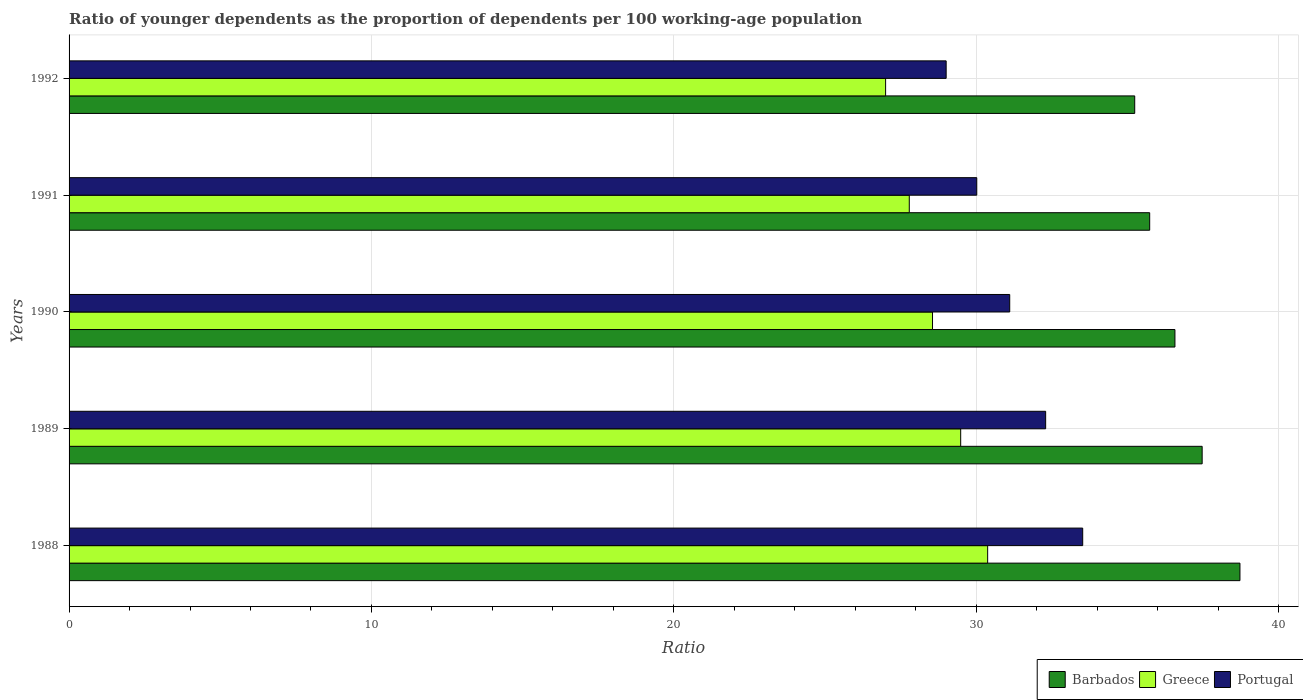How many different coloured bars are there?
Your answer should be very brief. 3. How many groups of bars are there?
Offer a very short reply. 5. Are the number of bars on each tick of the Y-axis equal?
Provide a succinct answer. Yes. How many bars are there on the 2nd tick from the bottom?
Your response must be concise. 3. In how many cases, is the number of bars for a given year not equal to the number of legend labels?
Give a very brief answer. 0. What is the age dependency ratio(young) in Barbados in 1990?
Your answer should be compact. 36.57. Across all years, what is the maximum age dependency ratio(young) in Barbados?
Ensure brevity in your answer.  38.72. Across all years, what is the minimum age dependency ratio(young) in Portugal?
Your answer should be compact. 29. In which year was the age dependency ratio(young) in Greece maximum?
Offer a terse response. 1988. What is the total age dependency ratio(young) in Portugal in the graph?
Your answer should be compact. 155.94. What is the difference between the age dependency ratio(young) in Portugal in 1989 and that in 1992?
Provide a short and direct response. 3.29. What is the difference between the age dependency ratio(young) in Greece in 1990 and the age dependency ratio(young) in Barbados in 1989?
Offer a very short reply. -8.92. What is the average age dependency ratio(young) in Greece per year?
Provide a short and direct response. 28.64. In the year 1992, what is the difference between the age dependency ratio(young) in Barbados and age dependency ratio(young) in Greece?
Make the answer very short. 8.24. What is the ratio of the age dependency ratio(young) in Barbados in 1989 to that in 1992?
Offer a very short reply. 1.06. Is the difference between the age dependency ratio(young) in Barbados in 1988 and 1991 greater than the difference between the age dependency ratio(young) in Greece in 1988 and 1991?
Provide a short and direct response. Yes. What is the difference between the highest and the second highest age dependency ratio(young) in Barbados?
Your answer should be very brief. 1.25. What is the difference between the highest and the lowest age dependency ratio(young) in Greece?
Offer a very short reply. 3.37. In how many years, is the age dependency ratio(young) in Portugal greater than the average age dependency ratio(young) in Portugal taken over all years?
Make the answer very short. 2. Is the sum of the age dependency ratio(young) in Greece in 1988 and 1990 greater than the maximum age dependency ratio(young) in Barbados across all years?
Your response must be concise. Yes. What does the 1st bar from the bottom in 1988 represents?
Make the answer very short. Barbados. Are the values on the major ticks of X-axis written in scientific E-notation?
Offer a terse response. No. Where does the legend appear in the graph?
Offer a terse response. Bottom right. What is the title of the graph?
Provide a succinct answer. Ratio of younger dependents as the proportion of dependents per 100 working-age population. Does "Central Europe" appear as one of the legend labels in the graph?
Give a very brief answer. No. What is the label or title of the X-axis?
Keep it short and to the point. Ratio. What is the label or title of the Y-axis?
Make the answer very short. Years. What is the Ratio of Barbados in 1988?
Keep it short and to the point. 38.72. What is the Ratio in Greece in 1988?
Make the answer very short. 30.38. What is the Ratio in Portugal in 1988?
Give a very brief answer. 33.52. What is the Ratio of Barbados in 1989?
Keep it short and to the point. 37.47. What is the Ratio in Greece in 1989?
Provide a succinct answer. 29.49. What is the Ratio in Portugal in 1989?
Your response must be concise. 32.3. What is the Ratio in Barbados in 1990?
Your answer should be very brief. 36.57. What is the Ratio of Greece in 1990?
Offer a terse response. 28.55. What is the Ratio in Portugal in 1990?
Keep it short and to the point. 31.11. What is the Ratio of Barbados in 1991?
Give a very brief answer. 35.74. What is the Ratio of Greece in 1991?
Provide a succinct answer. 27.79. What is the Ratio in Portugal in 1991?
Offer a very short reply. 30.02. What is the Ratio in Barbados in 1992?
Give a very brief answer. 35.24. What is the Ratio of Greece in 1992?
Your response must be concise. 27. What is the Ratio of Portugal in 1992?
Ensure brevity in your answer.  29. Across all years, what is the maximum Ratio of Barbados?
Your response must be concise. 38.72. Across all years, what is the maximum Ratio of Greece?
Keep it short and to the point. 30.38. Across all years, what is the maximum Ratio of Portugal?
Offer a very short reply. 33.52. Across all years, what is the minimum Ratio in Barbados?
Make the answer very short. 35.24. Across all years, what is the minimum Ratio in Greece?
Provide a succinct answer. 27. Across all years, what is the minimum Ratio in Portugal?
Your answer should be very brief. 29. What is the total Ratio in Barbados in the graph?
Provide a succinct answer. 183.74. What is the total Ratio of Greece in the graph?
Keep it short and to the point. 143.2. What is the total Ratio of Portugal in the graph?
Your answer should be compact. 155.94. What is the difference between the Ratio in Barbados in 1988 and that in 1989?
Provide a succinct answer. 1.25. What is the difference between the Ratio of Greece in 1988 and that in 1989?
Give a very brief answer. 0.89. What is the difference between the Ratio in Portugal in 1988 and that in 1989?
Your answer should be compact. 1.23. What is the difference between the Ratio in Barbados in 1988 and that in 1990?
Give a very brief answer. 2.15. What is the difference between the Ratio in Greece in 1988 and that in 1990?
Offer a terse response. 1.82. What is the difference between the Ratio of Portugal in 1988 and that in 1990?
Provide a succinct answer. 2.41. What is the difference between the Ratio in Barbados in 1988 and that in 1991?
Provide a short and direct response. 2.98. What is the difference between the Ratio of Greece in 1988 and that in 1991?
Give a very brief answer. 2.59. What is the difference between the Ratio of Portugal in 1988 and that in 1991?
Your answer should be very brief. 3.5. What is the difference between the Ratio in Barbados in 1988 and that in 1992?
Offer a terse response. 3.48. What is the difference between the Ratio of Greece in 1988 and that in 1992?
Offer a very short reply. 3.37. What is the difference between the Ratio in Portugal in 1988 and that in 1992?
Offer a very short reply. 4.52. What is the difference between the Ratio in Barbados in 1989 and that in 1990?
Keep it short and to the point. 0.9. What is the difference between the Ratio in Greece in 1989 and that in 1990?
Ensure brevity in your answer.  0.93. What is the difference between the Ratio in Portugal in 1989 and that in 1990?
Keep it short and to the point. 1.19. What is the difference between the Ratio of Barbados in 1989 and that in 1991?
Provide a short and direct response. 1.74. What is the difference between the Ratio in Greece in 1989 and that in 1991?
Provide a succinct answer. 1.7. What is the difference between the Ratio of Portugal in 1989 and that in 1991?
Your answer should be very brief. 2.28. What is the difference between the Ratio of Barbados in 1989 and that in 1992?
Provide a succinct answer. 2.23. What is the difference between the Ratio in Greece in 1989 and that in 1992?
Provide a succinct answer. 2.48. What is the difference between the Ratio in Portugal in 1989 and that in 1992?
Provide a short and direct response. 3.29. What is the difference between the Ratio in Barbados in 1990 and that in 1991?
Offer a terse response. 0.83. What is the difference between the Ratio in Greece in 1990 and that in 1991?
Your response must be concise. 0.77. What is the difference between the Ratio of Portugal in 1990 and that in 1991?
Make the answer very short. 1.09. What is the difference between the Ratio in Barbados in 1990 and that in 1992?
Give a very brief answer. 1.33. What is the difference between the Ratio in Greece in 1990 and that in 1992?
Provide a short and direct response. 1.55. What is the difference between the Ratio of Portugal in 1990 and that in 1992?
Make the answer very short. 2.1. What is the difference between the Ratio of Barbados in 1991 and that in 1992?
Your answer should be compact. 0.49. What is the difference between the Ratio in Greece in 1991 and that in 1992?
Ensure brevity in your answer.  0.78. What is the difference between the Ratio of Portugal in 1991 and that in 1992?
Offer a terse response. 1.01. What is the difference between the Ratio in Barbados in 1988 and the Ratio in Greece in 1989?
Your answer should be very brief. 9.23. What is the difference between the Ratio in Barbados in 1988 and the Ratio in Portugal in 1989?
Your answer should be compact. 6.43. What is the difference between the Ratio in Greece in 1988 and the Ratio in Portugal in 1989?
Your answer should be compact. -1.92. What is the difference between the Ratio of Barbados in 1988 and the Ratio of Greece in 1990?
Provide a succinct answer. 10.17. What is the difference between the Ratio in Barbados in 1988 and the Ratio in Portugal in 1990?
Your answer should be compact. 7.61. What is the difference between the Ratio in Greece in 1988 and the Ratio in Portugal in 1990?
Your answer should be very brief. -0.73. What is the difference between the Ratio of Barbados in 1988 and the Ratio of Greece in 1991?
Ensure brevity in your answer.  10.94. What is the difference between the Ratio in Barbados in 1988 and the Ratio in Portugal in 1991?
Provide a succinct answer. 8.7. What is the difference between the Ratio in Greece in 1988 and the Ratio in Portugal in 1991?
Your answer should be very brief. 0.36. What is the difference between the Ratio in Barbados in 1988 and the Ratio in Greece in 1992?
Give a very brief answer. 11.72. What is the difference between the Ratio in Barbados in 1988 and the Ratio in Portugal in 1992?
Provide a succinct answer. 9.72. What is the difference between the Ratio in Greece in 1988 and the Ratio in Portugal in 1992?
Ensure brevity in your answer.  1.37. What is the difference between the Ratio of Barbados in 1989 and the Ratio of Greece in 1990?
Provide a succinct answer. 8.92. What is the difference between the Ratio in Barbados in 1989 and the Ratio in Portugal in 1990?
Your answer should be compact. 6.36. What is the difference between the Ratio in Greece in 1989 and the Ratio in Portugal in 1990?
Your answer should be compact. -1.62. What is the difference between the Ratio of Barbados in 1989 and the Ratio of Greece in 1991?
Provide a succinct answer. 9.69. What is the difference between the Ratio in Barbados in 1989 and the Ratio in Portugal in 1991?
Offer a very short reply. 7.45. What is the difference between the Ratio in Greece in 1989 and the Ratio in Portugal in 1991?
Ensure brevity in your answer.  -0.53. What is the difference between the Ratio of Barbados in 1989 and the Ratio of Greece in 1992?
Give a very brief answer. 10.47. What is the difference between the Ratio of Barbados in 1989 and the Ratio of Portugal in 1992?
Keep it short and to the point. 8.47. What is the difference between the Ratio of Greece in 1989 and the Ratio of Portugal in 1992?
Give a very brief answer. 0.48. What is the difference between the Ratio in Barbados in 1990 and the Ratio in Greece in 1991?
Make the answer very short. 8.79. What is the difference between the Ratio in Barbados in 1990 and the Ratio in Portugal in 1991?
Your response must be concise. 6.55. What is the difference between the Ratio of Greece in 1990 and the Ratio of Portugal in 1991?
Give a very brief answer. -1.46. What is the difference between the Ratio of Barbados in 1990 and the Ratio of Greece in 1992?
Offer a very short reply. 9.57. What is the difference between the Ratio in Barbados in 1990 and the Ratio in Portugal in 1992?
Your answer should be very brief. 7.57. What is the difference between the Ratio of Greece in 1990 and the Ratio of Portugal in 1992?
Your response must be concise. -0.45. What is the difference between the Ratio of Barbados in 1991 and the Ratio of Greece in 1992?
Provide a short and direct response. 8.73. What is the difference between the Ratio in Barbados in 1991 and the Ratio in Portugal in 1992?
Make the answer very short. 6.73. What is the difference between the Ratio of Greece in 1991 and the Ratio of Portugal in 1992?
Ensure brevity in your answer.  -1.22. What is the average Ratio in Barbados per year?
Ensure brevity in your answer.  36.75. What is the average Ratio in Greece per year?
Ensure brevity in your answer.  28.64. What is the average Ratio in Portugal per year?
Your response must be concise. 31.19. In the year 1988, what is the difference between the Ratio of Barbados and Ratio of Greece?
Provide a succinct answer. 8.34. In the year 1988, what is the difference between the Ratio of Barbados and Ratio of Portugal?
Your answer should be very brief. 5.2. In the year 1988, what is the difference between the Ratio of Greece and Ratio of Portugal?
Offer a very short reply. -3.14. In the year 1989, what is the difference between the Ratio in Barbados and Ratio in Greece?
Offer a terse response. 7.99. In the year 1989, what is the difference between the Ratio in Barbados and Ratio in Portugal?
Keep it short and to the point. 5.18. In the year 1989, what is the difference between the Ratio in Greece and Ratio in Portugal?
Your answer should be very brief. -2.81. In the year 1990, what is the difference between the Ratio of Barbados and Ratio of Greece?
Ensure brevity in your answer.  8.02. In the year 1990, what is the difference between the Ratio in Barbados and Ratio in Portugal?
Make the answer very short. 5.46. In the year 1990, what is the difference between the Ratio in Greece and Ratio in Portugal?
Your response must be concise. -2.55. In the year 1991, what is the difference between the Ratio of Barbados and Ratio of Greece?
Give a very brief answer. 7.95. In the year 1991, what is the difference between the Ratio of Barbados and Ratio of Portugal?
Ensure brevity in your answer.  5.72. In the year 1991, what is the difference between the Ratio of Greece and Ratio of Portugal?
Give a very brief answer. -2.23. In the year 1992, what is the difference between the Ratio of Barbados and Ratio of Greece?
Give a very brief answer. 8.24. In the year 1992, what is the difference between the Ratio of Barbados and Ratio of Portugal?
Offer a very short reply. 6.24. In the year 1992, what is the difference between the Ratio in Greece and Ratio in Portugal?
Your answer should be very brief. -2. What is the ratio of the Ratio of Barbados in 1988 to that in 1989?
Your response must be concise. 1.03. What is the ratio of the Ratio of Greece in 1988 to that in 1989?
Your answer should be very brief. 1.03. What is the ratio of the Ratio of Portugal in 1988 to that in 1989?
Make the answer very short. 1.04. What is the ratio of the Ratio of Barbados in 1988 to that in 1990?
Your response must be concise. 1.06. What is the ratio of the Ratio in Greece in 1988 to that in 1990?
Offer a very short reply. 1.06. What is the ratio of the Ratio of Portugal in 1988 to that in 1990?
Make the answer very short. 1.08. What is the ratio of the Ratio of Barbados in 1988 to that in 1991?
Offer a very short reply. 1.08. What is the ratio of the Ratio in Greece in 1988 to that in 1991?
Give a very brief answer. 1.09. What is the ratio of the Ratio in Portugal in 1988 to that in 1991?
Your answer should be very brief. 1.12. What is the ratio of the Ratio of Barbados in 1988 to that in 1992?
Keep it short and to the point. 1.1. What is the ratio of the Ratio of Portugal in 1988 to that in 1992?
Your answer should be very brief. 1.16. What is the ratio of the Ratio of Barbados in 1989 to that in 1990?
Make the answer very short. 1.02. What is the ratio of the Ratio of Greece in 1989 to that in 1990?
Provide a succinct answer. 1.03. What is the ratio of the Ratio of Portugal in 1989 to that in 1990?
Your answer should be compact. 1.04. What is the ratio of the Ratio of Barbados in 1989 to that in 1991?
Your response must be concise. 1.05. What is the ratio of the Ratio of Greece in 1989 to that in 1991?
Keep it short and to the point. 1.06. What is the ratio of the Ratio of Portugal in 1989 to that in 1991?
Provide a succinct answer. 1.08. What is the ratio of the Ratio of Barbados in 1989 to that in 1992?
Your answer should be very brief. 1.06. What is the ratio of the Ratio of Greece in 1989 to that in 1992?
Provide a succinct answer. 1.09. What is the ratio of the Ratio in Portugal in 1989 to that in 1992?
Your response must be concise. 1.11. What is the ratio of the Ratio in Barbados in 1990 to that in 1991?
Provide a succinct answer. 1.02. What is the ratio of the Ratio in Greece in 1990 to that in 1991?
Provide a succinct answer. 1.03. What is the ratio of the Ratio of Portugal in 1990 to that in 1991?
Keep it short and to the point. 1.04. What is the ratio of the Ratio of Barbados in 1990 to that in 1992?
Give a very brief answer. 1.04. What is the ratio of the Ratio in Greece in 1990 to that in 1992?
Offer a very short reply. 1.06. What is the ratio of the Ratio in Portugal in 1990 to that in 1992?
Your response must be concise. 1.07. What is the ratio of the Ratio of Portugal in 1991 to that in 1992?
Provide a succinct answer. 1.03. What is the difference between the highest and the second highest Ratio in Barbados?
Your response must be concise. 1.25. What is the difference between the highest and the second highest Ratio in Greece?
Your answer should be compact. 0.89. What is the difference between the highest and the second highest Ratio of Portugal?
Your answer should be very brief. 1.23. What is the difference between the highest and the lowest Ratio of Barbados?
Offer a very short reply. 3.48. What is the difference between the highest and the lowest Ratio in Greece?
Offer a very short reply. 3.37. What is the difference between the highest and the lowest Ratio of Portugal?
Your answer should be compact. 4.52. 